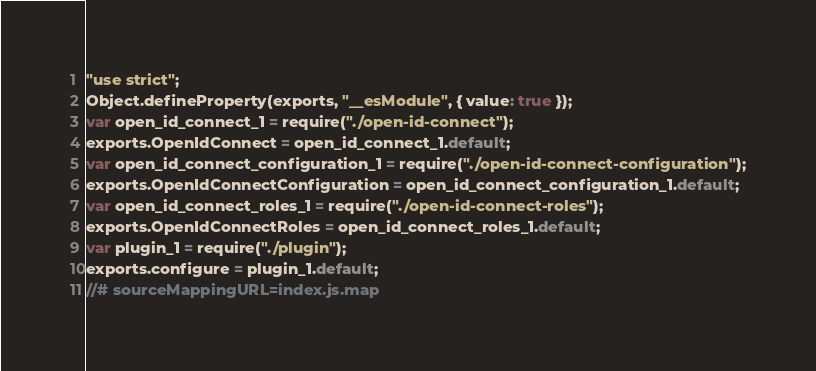Convert code to text. <code><loc_0><loc_0><loc_500><loc_500><_JavaScript_>"use strict";
Object.defineProperty(exports, "__esModule", { value: true });
var open_id_connect_1 = require("./open-id-connect");
exports.OpenIdConnect = open_id_connect_1.default;
var open_id_connect_configuration_1 = require("./open-id-connect-configuration");
exports.OpenIdConnectConfiguration = open_id_connect_configuration_1.default;
var open_id_connect_roles_1 = require("./open-id-connect-roles");
exports.OpenIdConnectRoles = open_id_connect_roles_1.default;
var plugin_1 = require("./plugin");
exports.configure = plugin_1.default;
//# sourceMappingURL=index.js.map</code> 